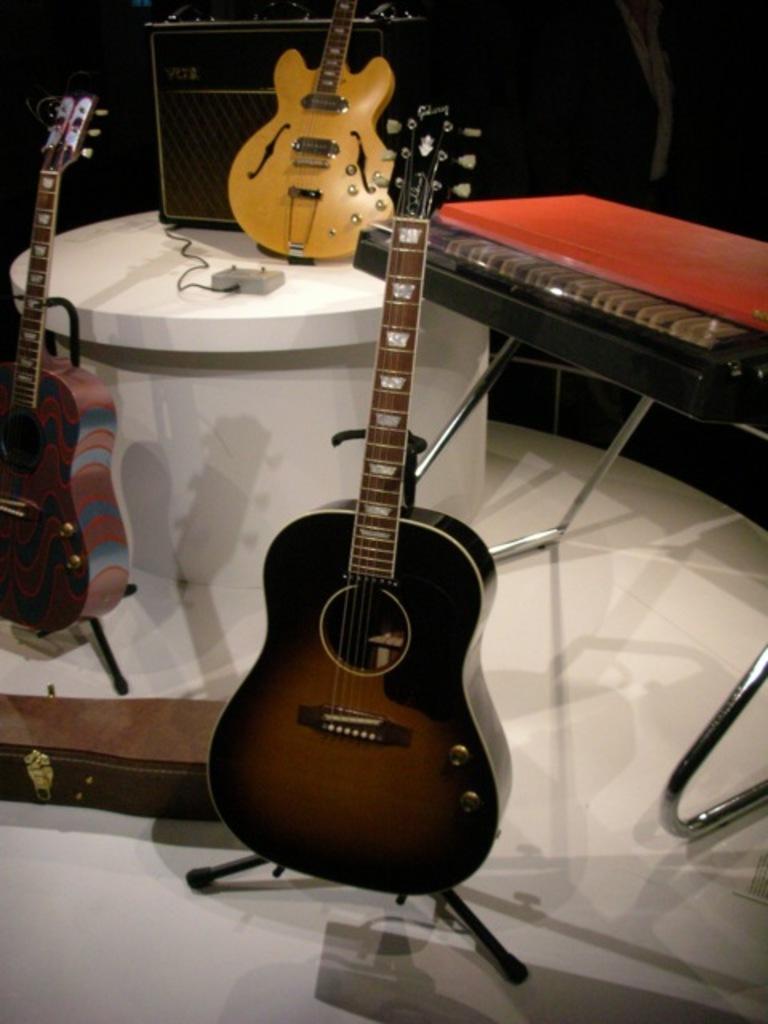Describe this image in one or two sentences. This image there are 3 guitars where 1 guitar is kept in the stand , guitar case , another guitar kept for a hook , another guitar in the table and at the background there is a speaker and a table. 